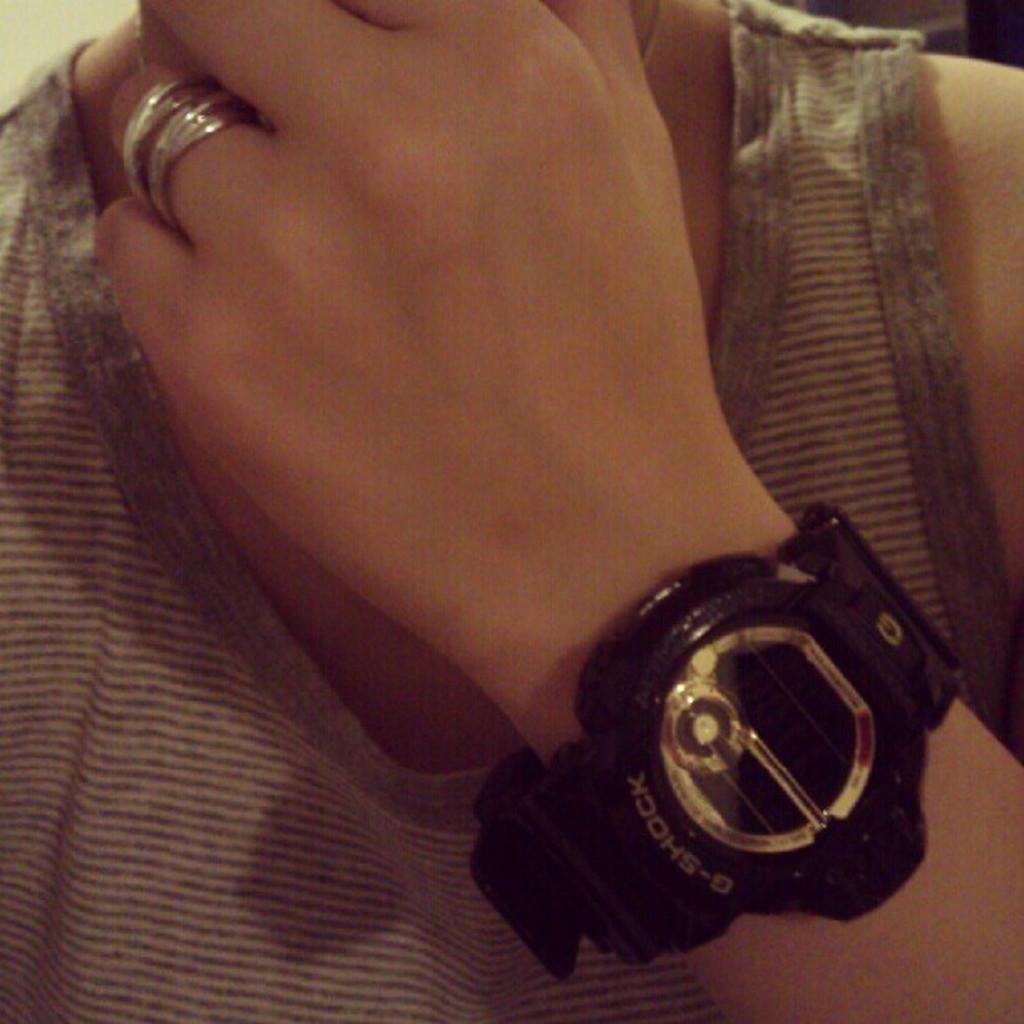Describe this image in one or two sentences. In this image we can see a person wearing rings and a wristwatch on his hand. 